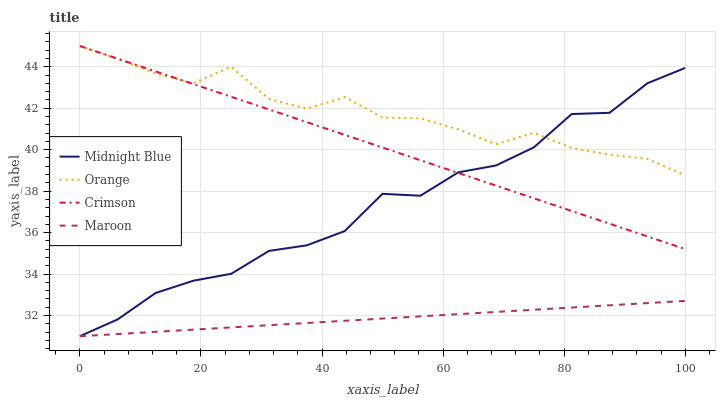Does Maroon have the minimum area under the curve?
Answer yes or no. Yes. Does Orange have the maximum area under the curve?
Answer yes or no. Yes. Does Crimson have the minimum area under the curve?
Answer yes or no. No. Does Crimson have the maximum area under the curve?
Answer yes or no. No. Is Maroon the smoothest?
Answer yes or no. Yes. Is Midnight Blue the roughest?
Answer yes or no. Yes. Is Crimson the smoothest?
Answer yes or no. No. Is Crimson the roughest?
Answer yes or no. No. Does Crimson have the lowest value?
Answer yes or no. No. Does Midnight Blue have the highest value?
Answer yes or no. No. Is Maroon less than Orange?
Answer yes or no. Yes. Is Orange greater than Maroon?
Answer yes or no. Yes. Does Maroon intersect Orange?
Answer yes or no. No. 